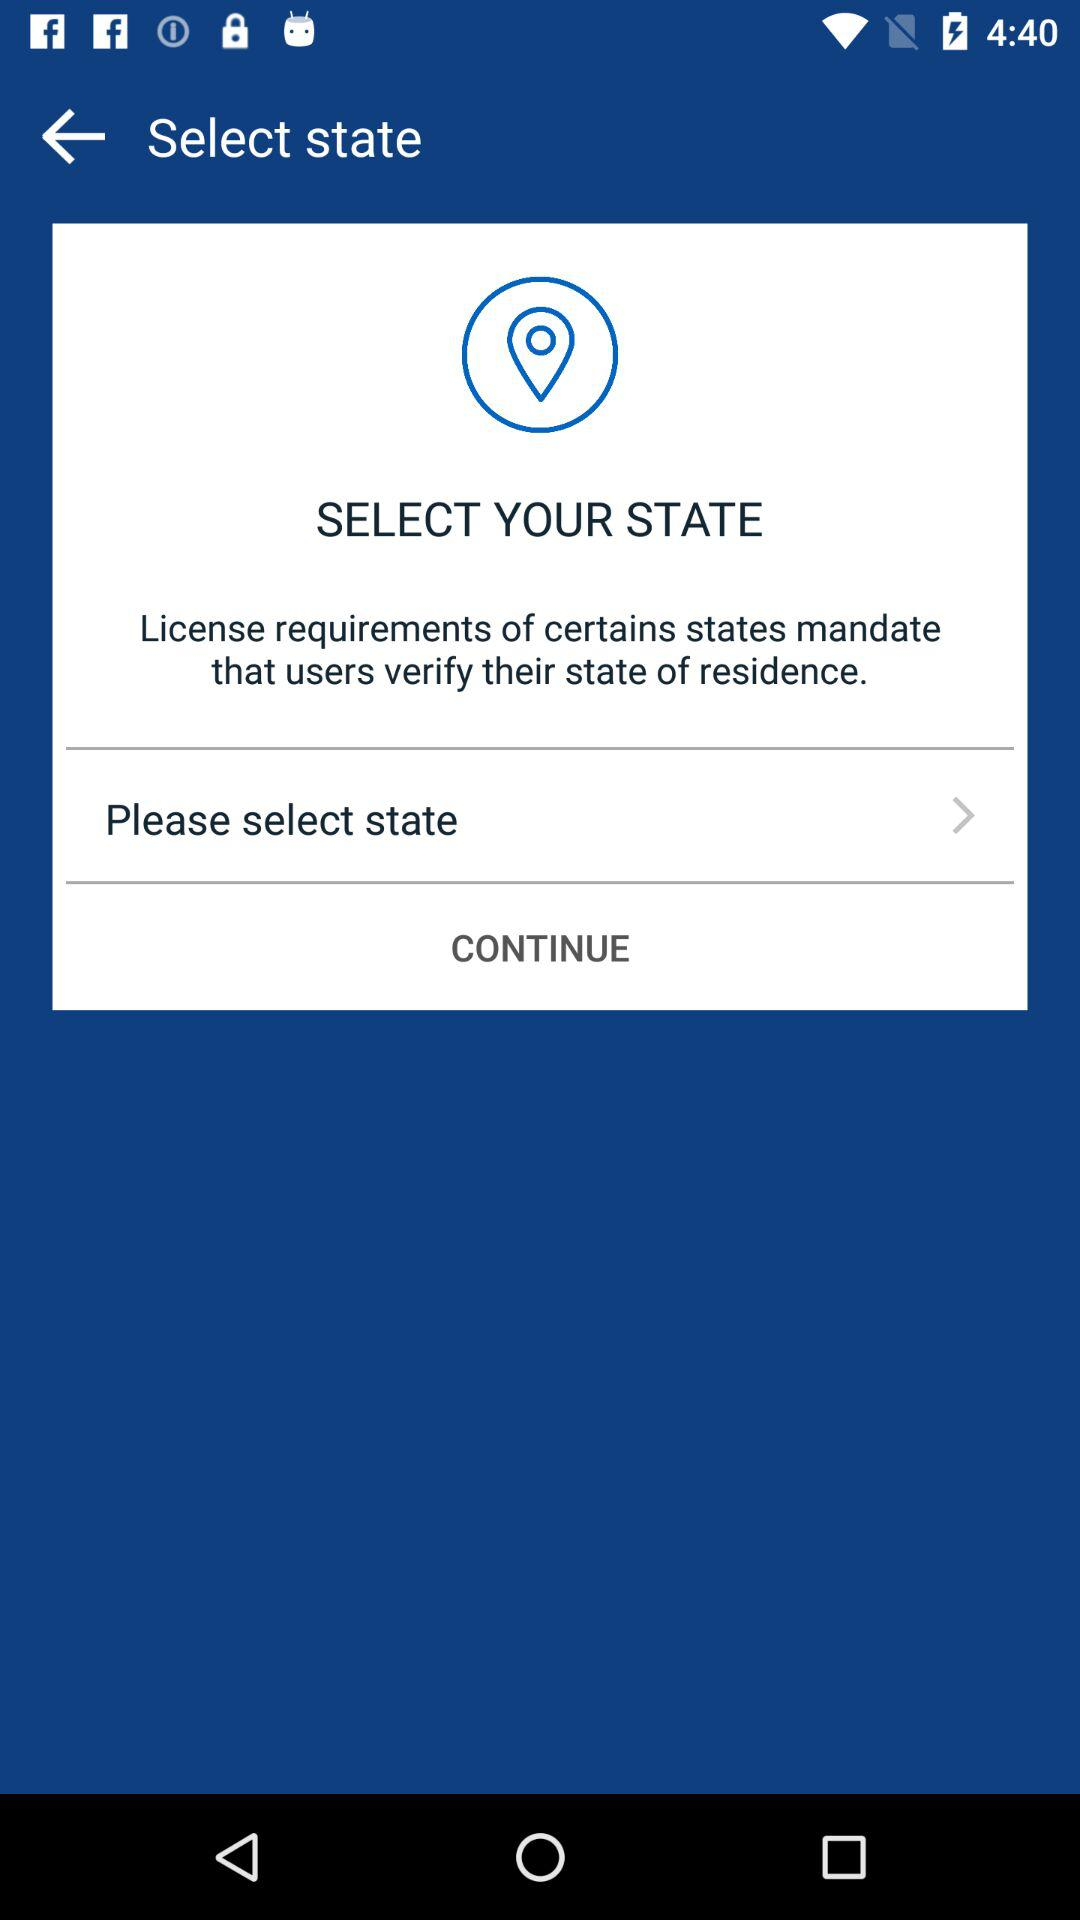Which option is selected, "BTC" or "ETH", in "coinbase"? In "coinbase", the selected option is "BTC". 